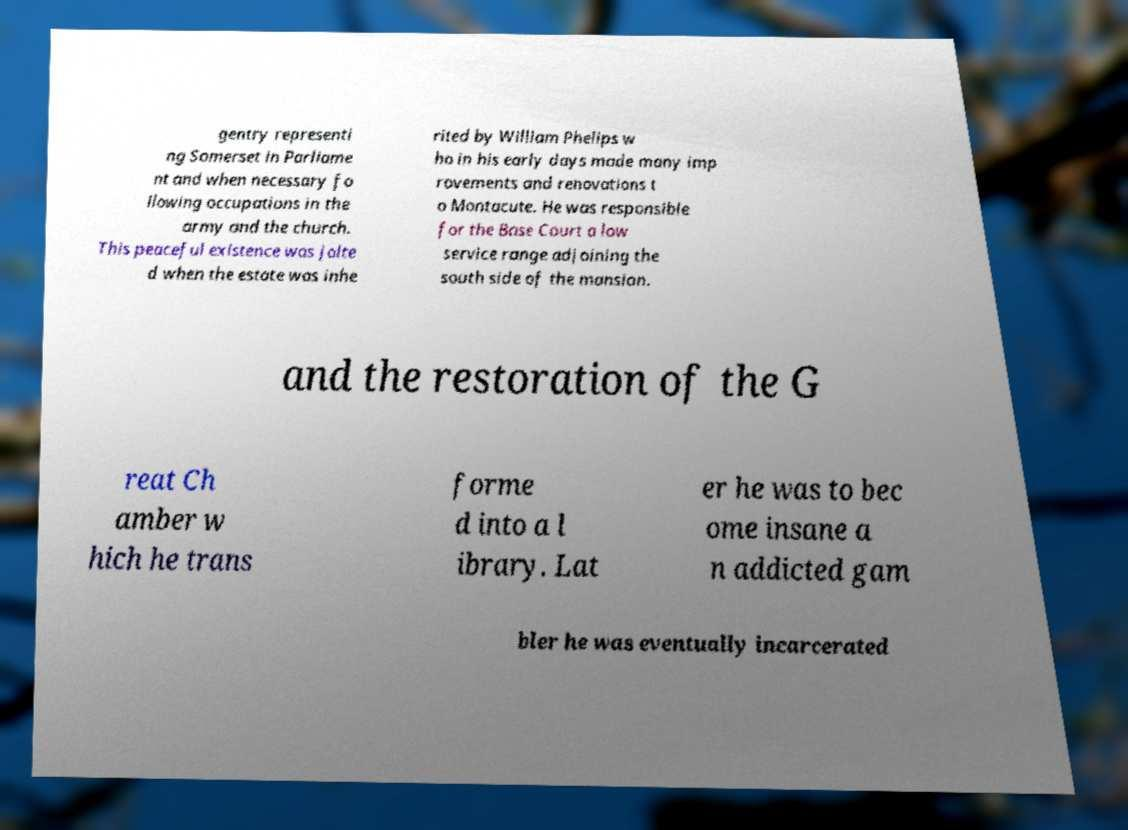Could you assist in decoding the text presented in this image and type it out clearly? gentry representi ng Somerset in Parliame nt and when necessary fo llowing occupations in the army and the church. This peaceful existence was jolte d when the estate was inhe rited by William Phelips w ho in his early days made many imp rovements and renovations t o Montacute. He was responsible for the Base Court a low service range adjoining the south side of the mansion. and the restoration of the G reat Ch amber w hich he trans forme d into a l ibrary. Lat er he was to bec ome insane a n addicted gam bler he was eventually incarcerated 